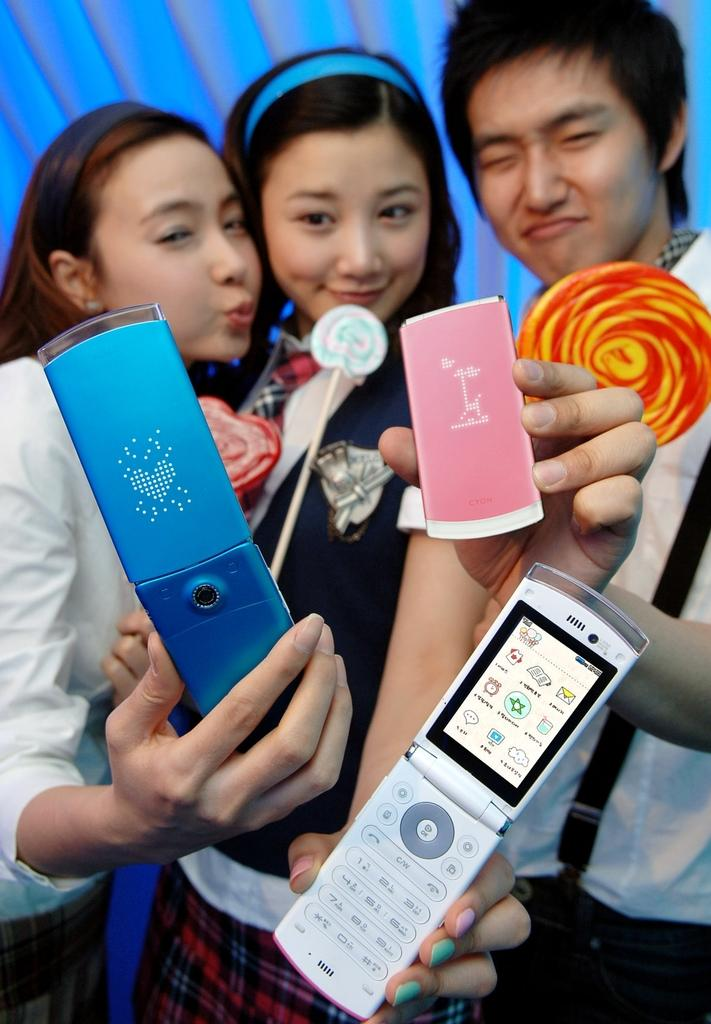How many people are in the image? There are three people in the image. Can you describe the gender of the people in the image? Two of the people are women, and one is a man. What is the man holding in his hand? The man is holding a mobile in his hand. What are the people holding in their other hands? The man and the women are holding lollipops in their other hands. What type of haircut does the man have in the image? There is no information about the man's haircut in the image. Where is the room located in the image? The image does not show a room; it only shows the three people holding lollipops and a mobile. 